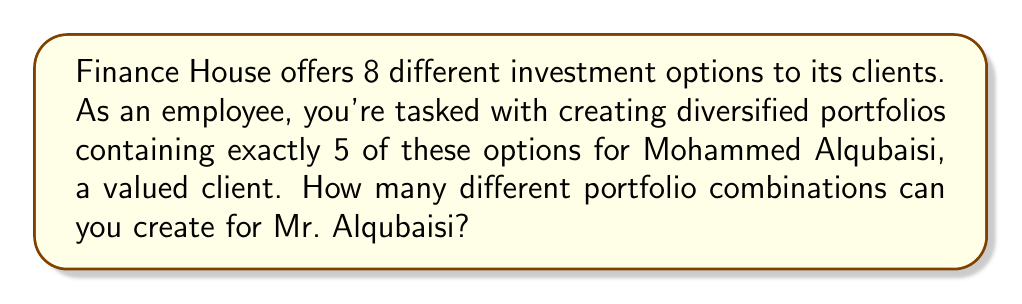Could you help me with this problem? To solve this problem, we need to use the combination formula. We are selecting 5 options out of 8 available options, where the order doesn't matter (since it's a portfolio composition).

The formula for combinations is:

$$ C(n,r) = \frac{n!}{r!(n-r)!} $$

Where:
$n$ is the total number of items to choose from (8 in this case)
$r$ is the number of items being chosen (5 in this case)

Let's substitute these values:

$$ C(8,5) = \frac{8!}{5!(8-5)!} = \frac{8!}{5!(3)!} $$

Now, let's calculate step by step:

1) $8! = 8 \times 7 \times 6 \times 5 \times 4 \times 3 \times 2 \times 1 = 40,320$
2) $5! = 5 \times 4 \times 3 \times 2 \times 1 = 120$
3) $3! = 3 \times 2 \times 1 = 6$

Substituting these values:

$$ \frac{40,320}{120 \times 6} = \frac{40,320}{720} = 56 $$

Therefore, you can create 56 different portfolio combinations for Mr. Alqubaisi.
Answer: 56 